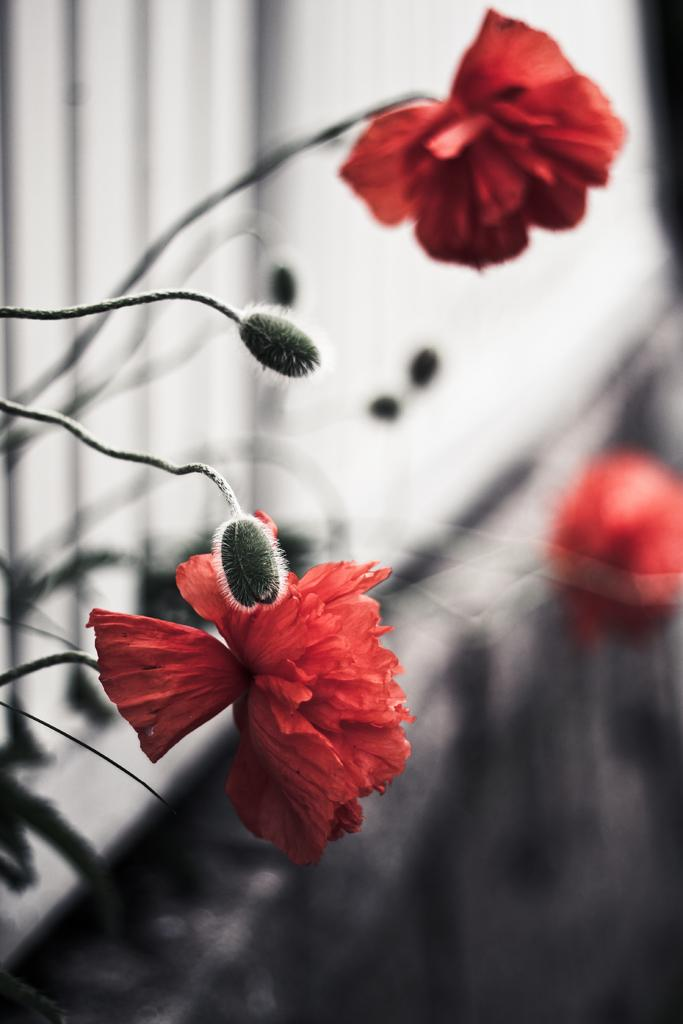What is the color scheme of the image? The image is black and white. Are there any specific elements that stand out in the image? Yes, flowers are highlighted in red color. How was the image altered or modified? The image is edited. How many pets are visible in the image? There are no pets visible in the image; it features flowers highlighted in red color. What type of curve can be seen in the image? There is no curve present in the image; it is a black and white image with red-highlighted flowers. 